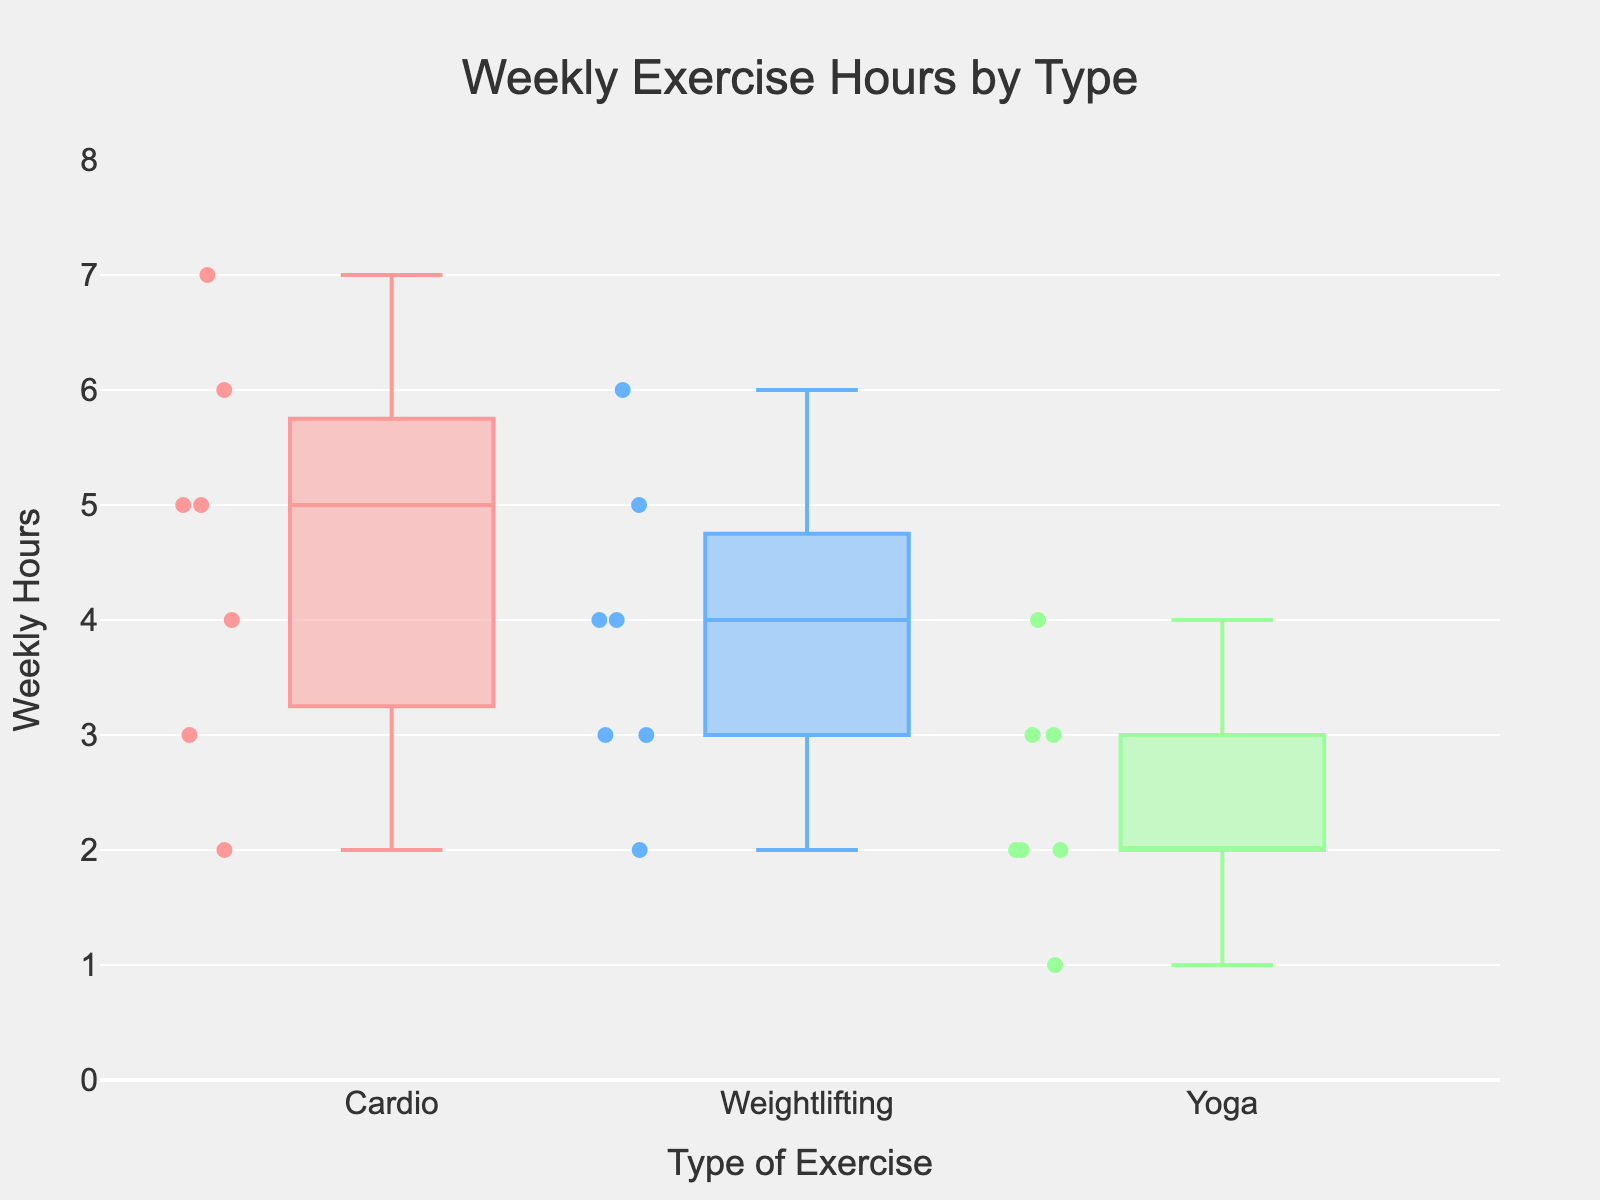What is the title of the figure? The title is usually placed at the top of the figure. In this case, it's clearly labeled in the layout setup.
Answer: Weekly Exercise Hours by Type What are the labels on the x-axis and y-axis? The x-axis usually indicates the different categories or groups, while the y-axis typically represents the numerical values. Here, the x-axis label is "Type of Exercise" and the y-axis label is "Weekly Hours."
Answer: Type of Exercise and Weekly Hours Which type of exercise has the widest range of weekly hours spent by participants? To determine the range, we look at the length of the boxes and the whiskers for each type of exercise. The widest range is from the bottom to the top of the whiskers.
Answer: Cardio What is the median weekly hours spent on Yoga? The median is represented by the line inside the box. For Yoga, it can be identified by viewing the position of the line within the Yoga box plot.
Answer: 2.5 weekly hours Which type of exercise has the highest median weekly hours? To find the highest median, compare the lines inside the boxes for each type of exercise. The one with the highest positioned median line indicates the highest median weekly hours spent.
Answer: Cardio Are there any outliers in the Cardio exercise box plot? Outliers are typically represented by dots outside the whiskers of the box plot. Check if there are any dots away from the whiskers in the Cardio box plot.
Answer: No What is the interquartile range (IQR) for Weightlifting? The IQR is the range between the 25th percentile (lower quartile) and the 75th percentile (upper quartile). Identify these points by the edges of the box in the Weightlifting plot.
Answer: 3 Between Cardio and Yoga, which has a smaller interquartile range (IQR)? Compare the lengths of the boxes (which represent the IQR) for Cardio and Yoga. The smaller box indicates a smaller IQR.
Answer: Yoga How many participants spent more than 5 hours on Weightlifting? Points representing participants above the 5-hour line in the Weightlifting box plot will be counted. Examine the plot above this threshold.
Answer: 1 What's the overall trend in weekly hours spent on different types of exercise? This requires summarizing the patterns observed in the box plots, including medians, ranges, and distribution spreads for each type of exercise.
Answer: Cardio generally has the highest median and range, followed by Weightlifting, with Yoga having the smallest range 